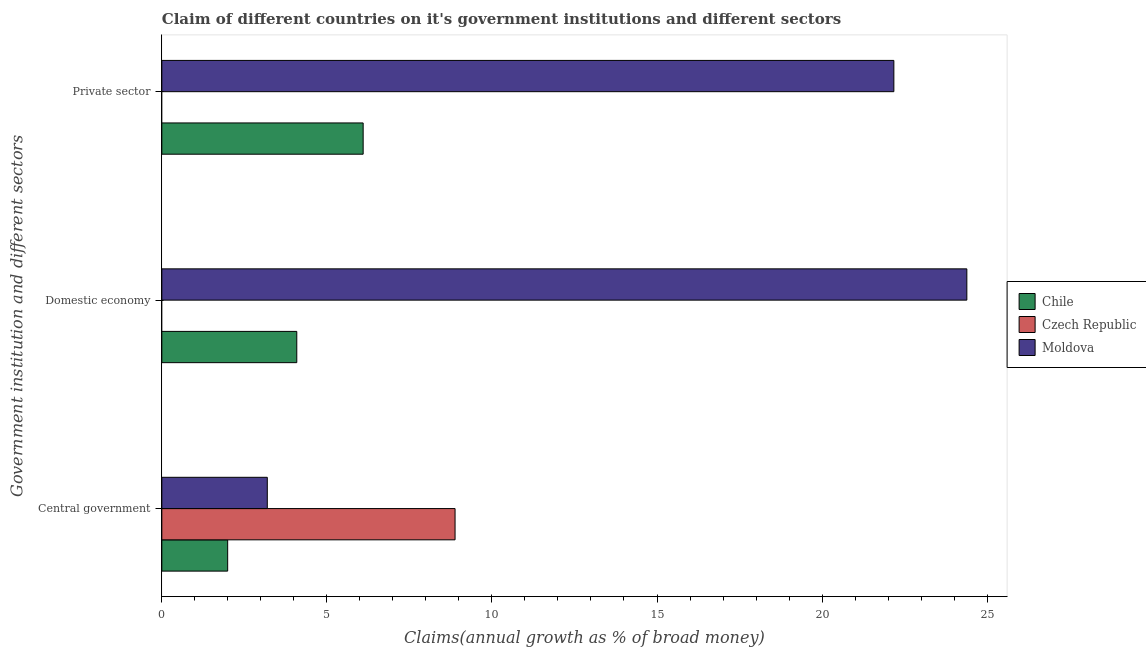Are the number of bars per tick equal to the number of legend labels?
Keep it short and to the point. No. How many bars are there on the 1st tick from the top?
Your answer should be compact. 2. What is the label of the 2nd group of bars from the top?
Provide a short and direct response. Domestic economy. What is the percentage of claim on the private sector in Chile?
Your answer should be compact. 6.1. Across all countries, what is the maximum percentage of claim on the central government?
Your answer should be compact. 8.88. In which country was the percentage of claim on the private sector maximum?
Your answer should be compact. Moldova. What is the total percentage of claim on the domestic economy in the graph?
Offer a terse response. 28.47. What is the difference between the percentage of claim on the private sector in Moldova and that in Chile?
Keep it short and to the point. 16.08. What is the difference between the percentage of claim on the central government in Czech Republic and the percentage of claim on the domestic economy in Moldova?
Give a very brief answer. -15.5. What is the average percentage of claim on the domestic economy per country?
Offer a very short reply. 9.49. What is the difference between the percentage of claim on the domestic economy and percentage of claim on the private sector in Chile?
Keep it short and to the point. -2.01. In how many countries, is the percentage of claim on the private sector greater than 10 %?
Offer a very short reply. 1. What is the ratio of the percentage of claim on the domestic economy in Chile to that in Moldova?
Provide a short and direct response. 0.17. Is the percentage of claim on the domestic economy in Moldova less than that in Chile?
Offer a terse response. No. What is the difference between the highest and the second highest percentage of claim on the central government?
Your answer should be very brief. 5.69. What is the difference between the highest and the lowest percentage of claim on the domestic economy?
Give a very brief answer. 24.39. In how many countries, is the percentage of claim on the domestic economy greater than the average percentage of claim on the domestic economy taken over all countries?
Your answer should be compact. 1. Are all the bars in the graph horizontal?
Your answer should be compact. Yes. Does the graph contain any zero values?
Make the answer very short. Yes. Does the graph contain grids?
Keep it short and to the point. No. How many legend labels are there?
Keep it short and to the point. 3. How are the legend labels stacked?
Keep it short and to the point. Vertical. What is the title of the graph?
Provide a short and direct response. Claim of different countries on it's government institutions and different sectors. What is the label or title of the X-axis?
Your answer should be compact. Claims(annual growth as % of broad money). What is the label or title of the Y-axis?
Provide a succinct answer. Government institution and different sectors. What is the Claims(annual growth as % of broad money) in Chile in Central government?
Ensure brevity in your answer.  1.99. What is the Claims(annual growth as % of broad money) in Czech Republic in Central government?
Provide a succinct answer. 8.88. What is the Claims(annual growth as % of broad money) of Moldova in Central government?
Your answer should be very brief. 3.19. What is the Claims(annual growth as % of broad money) in Chile in Domestic economy?
Offer a very short reply. 4.09. What is the Claims(annual growth as % of broad money) in Moldova in Domestic economy?
Give a very brief answer. 24.39. What is the Claims(annual growth as % of broad money) in Chile in Private sector?
Offer a terse response. 6.1. What is the Claims(annual growth as % of broad money) of Moldova in Private sector?
Provide a succinct answer. 22.18. Across all Government institution and different sectors, what is the maximum Claims(annual growth as % of broad money) in Chile?
Provide a short and direct response. 6.1. Across all Government institution and different sectors, what is the maximum Claims(annual growth as % of broad money) in Czech Republic?
Provide a succinct answer. 8.88. Across all Government institution and different sectors, what is the maximum Claims(annual growth as % of broad money) in Moldova?
Give a very brief answer. 24.39. Across all Government institution and different sectors, what is the minimum Claims(annual growth as % of broad money) of Chile?
Offer a very short reply. 1.99. Across all Government institution and different sectors, what is the minimum Claims(annual growth as % of broad money) of Moldova?
Make the answer very short. 3.19. What is the total Claims(annual growth as % of broad money) of Chile in the graph?
Provide a short and direct response. 12.18. What is the total Claims(annual growth as % of broad money) in Czech Republic in the graph?
Make the answer very short. 8.88. What is the total Claims(annual growth as % of broad money) of Moldova in the graph?
Offer a very short reply. 49.76. What is the difference between the Claims(annual growth as % of broad money) of Chile in Central government and that in Domestic economy?
Your answer should be very brief. -2.09. What is the difference between the Claims(annual growth as % of broad money) in Moldova in Central government and that in Domestic economy?
Give a very brief answer. -21.19. What is the difference between the Claims(annual growth as % of broad money) in Chile in Central government and that in Private sector?
Ensure brevity in your answer.  -4.1. What is the difference between the Claims(annual growth as % of broad money) in Moldova in Central government and that in Private sector?
Provide a short and direct response. -18.98. What is the difference between the Claims(annual growth as % of broad money) in Chile in Domestic economy and that in Private sector?
Offer a terse response. -2.01. What is the difference between the Claims(annual growth as % of broad money) of Moldova in Domestic economy and that in Private sector?
Your answer should be compact. 2.21. What is the difference between the Claims(annual growth as % of broad money) of Chile in Central government and the Claims(annual growth as % of broad money) of Moldova in Domestic economy?
Make the answer very short. -22.39. What is the difference between the Claims(annual growth as % of broad money) in Czech Republic in Central government and the Claims(annual growth as % of broad money) in Moldova in Domestic economy?
Offer a terse response. -15.5. What is the difference between the Claims(annual growth as % of broad money) of Chile in Central government and the Claims(annual growth as % of broad money) of Moldova in Private sector?
Offer a terse response. -20.18. What is the difference between the Claims(annual growth as % of broad money) in Czech Republic in Central government and the Claims(annual growth as % of broad money) in Moldova in Private sector?
Ensure brevity in your answer.  -13.29. What is the difference between the Claims(annual growth as % of broad money) in Chile in Domestic economy and the Claims(annual growth as % of broad money) in Moldova in Private sector?
Give a very brief answer. -18.09. What is the average Claims(annual growth as % of broad money) of Chile per Government institution and different sectors?
Keep it short and to the point. 4.06. What is the average Claims(annual growth as % of broad money) of Czech Republic per Government institution and different sectors?
Offer a very short reply. 2.96. What is the average Claims(annual growth as % of broad money) of Moldova per Government institution and different sectors?
Provide a succinct answer. 16.59. What is the difference between the Claims(annual growth as % of broad money) of Chile and Claims(annual growth as % of broad money) of Czech Republic in Central government?
Provide a short and direct response. -6.89. What is the difference between the Claims(annual growth as % of broad money) of Chile and Claims(annual growth as % of broad money) of Moldova in Central government?
Make the answer very short. -1.2. What is the difference between the Claims(annual growth as % of broad money) of Czech Republic and Claims(annual growth as % of broad money) of Moldova in Central government?
Offer a terse response. 5.69. What is the difference between the Claims(annual growth as % of broad money) in Chile and Claims(annual growth as % of broad money) in Moldova in Domestic economy?
Ensure brevity in your answer.  -20.3. What is the difference between the Claims(annual growth as % of broad money) in Chile and Claims(annual growth as % of broad money) in Moldova in Private sector?
Make the answer very short. -16.08. What is the ratio of the Claims(annual growth as % of broad money) of Chile in Central government to that in Domestic economy?
Your response must be concise. 0.49. What is the ratio of the Claims(annual growth as % of broad money) of Moldova in Central government to that in Domestic economy?
Your answer should be compact. 0.13. What is the ratio of the Claims(annual growth as % of broad money) of Chile in Central government to that in Private sector?
Provide a succinct answer. 0.33. What is the ratio of the Claims(annual growth as % of broad money) of Moldova in Central government to that in Private sector?
Offer a very short reply. 0.14. What is the ratio of the Claims(annual growth as % of broad money) of Chile in Domestic economy to that in Private sector?
Give a very brief answer. 0.67. What is the ratio of the Claims(annual growth as % of broad money) of Moldova in Domestic economy to that in Private sector?
Keep it short and to the point. 1.1. What is the difference between the highest and the second highest Claims(annual growth as % of broad money) in Chile?
Offer a terse response. 2.01. What is the difference between the highest and the second highest Claims(annual growth as % of broad money) of Moldova?
Your answer should be compact. 2.21. What is the difference between the highest and the lowest Claims(annual growth as % of broad money) of Chile?
Your answer should be compact. 4.1. What is the difference between the highest and the lowest Claims(annual growth as % of broad money) of Czech Republic?
Provide a short and direct response. 8.88. What is the difference between the highest and the lowest Claims(annual growth as % of broad money) of Moldova?
Make the answer very short. 21.19. 